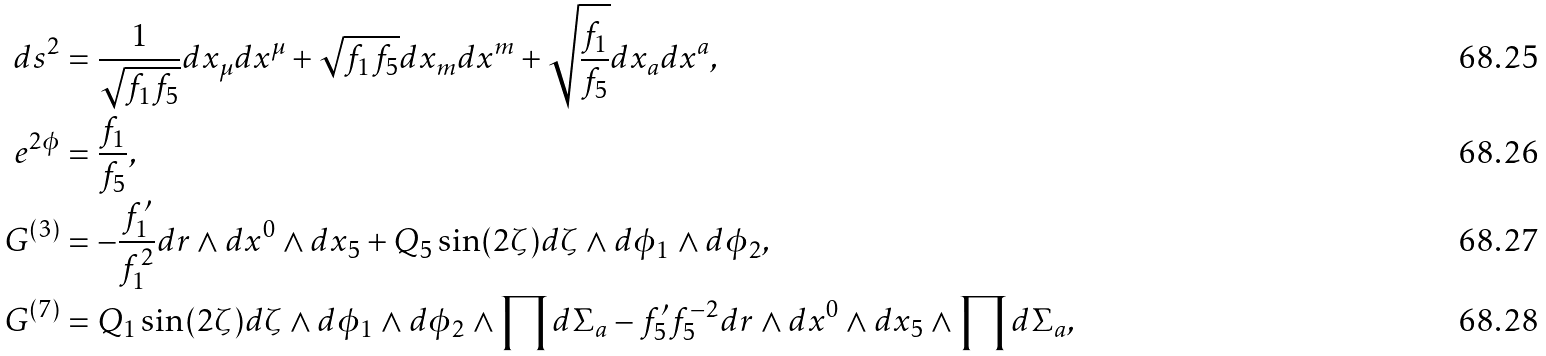Convert formula to latex. <formula><loc_0><loc_0><loc_500><loc_500>d s ^ { 2 } & = \frac { 1 } { \sqrt { f _ { 1 } f _ { 5 } } } d x _ { \mu } d x ^ { \mu } + \sqrt { f _ { 1 } f _ { 5 } } d x _ { m } d x ^ { m } + \sqrt { \frac { f _ { 1 } } { f _ { 5 } } } d x _ { a } d x ^ { a } , \\ e ^ { 2 \phi } & = \frac { f _ { 1 } } { f _ { 5 } } , \\ G ^ { ( 3 ) } & = - \frac { f _ { 1 } ^ { \prime } } { f _ { 1 } ^ { 2 } } d r \wedge d x ^ { 0 } \wedge d x _ { 5 } + Q _ { 5 } \sin ( 2 \zeta ) d \zeta \wedge d \phi _ { 1 } \wedge d \phi _ { 2 } , \\ G ^ { ( 7 ) } & = Q _ { 1 } \sin ( 2 \zeta ) d \zeta \wedge d \phi _ { 1 } \wedge d \phi _ { 2 } \wedge \prod d \Sigma _ { a } - f _ { 5 } ^ { \prime } f _ { 5 } ^ { - 2 } d r \wedge d x ^ { 0 } \wedge d x _ { 5 } \wedge \prod d \Sigma _ { a } ,</formula> 